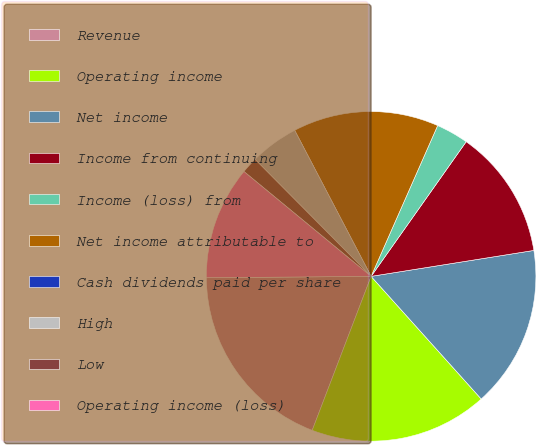Convert chart. <chart><loc_0><loc_0><loc_500><loc_500><pie_chart><fcel>Revenue<fcel>Operating income<fcel>Net income<fcel>Income from continuing<fcel>Income (loss) from<fcel>Net income attributable to<fcel>Cash dividends paid per share<fcel>High<fcel>Low<fcel>Operating income (loss)<nl><fcel>19.05%<fcel>17.46%<fcel>15.87%<fcel>12.7%<fcel>3.17%<fcel>14.29%<fcel>0.0%<fcel>4.76%<fcel>1.59%<fcel>11.11%<nl></chart> 